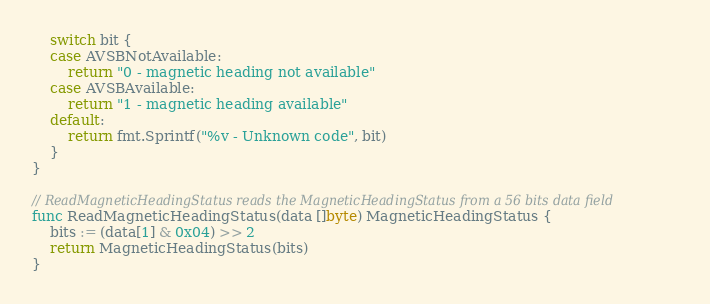<code> <loc_0><loc_0><loc_500><loc_500><_Go_>
	switch bit {
	case AVSBNotAvailable:
		return "0 - magnetic heading not available"
	case AVSBAvailable:
		return "1 - magnetic heading available"
	default:
		return fmt.Sprintf("%v - Unknown code", bit)
	}
}

// ReadMagneticHeadingStatus reads the MagneticHeadingStatus from a 56 bits data field
func ReadMagneticHeadingStatus(data []byte) MagneticHeadingStatus {
	bits := (data[1] & 0x04) >> 2
	return MagneticHeadingStatus(bits)
}
</code> 